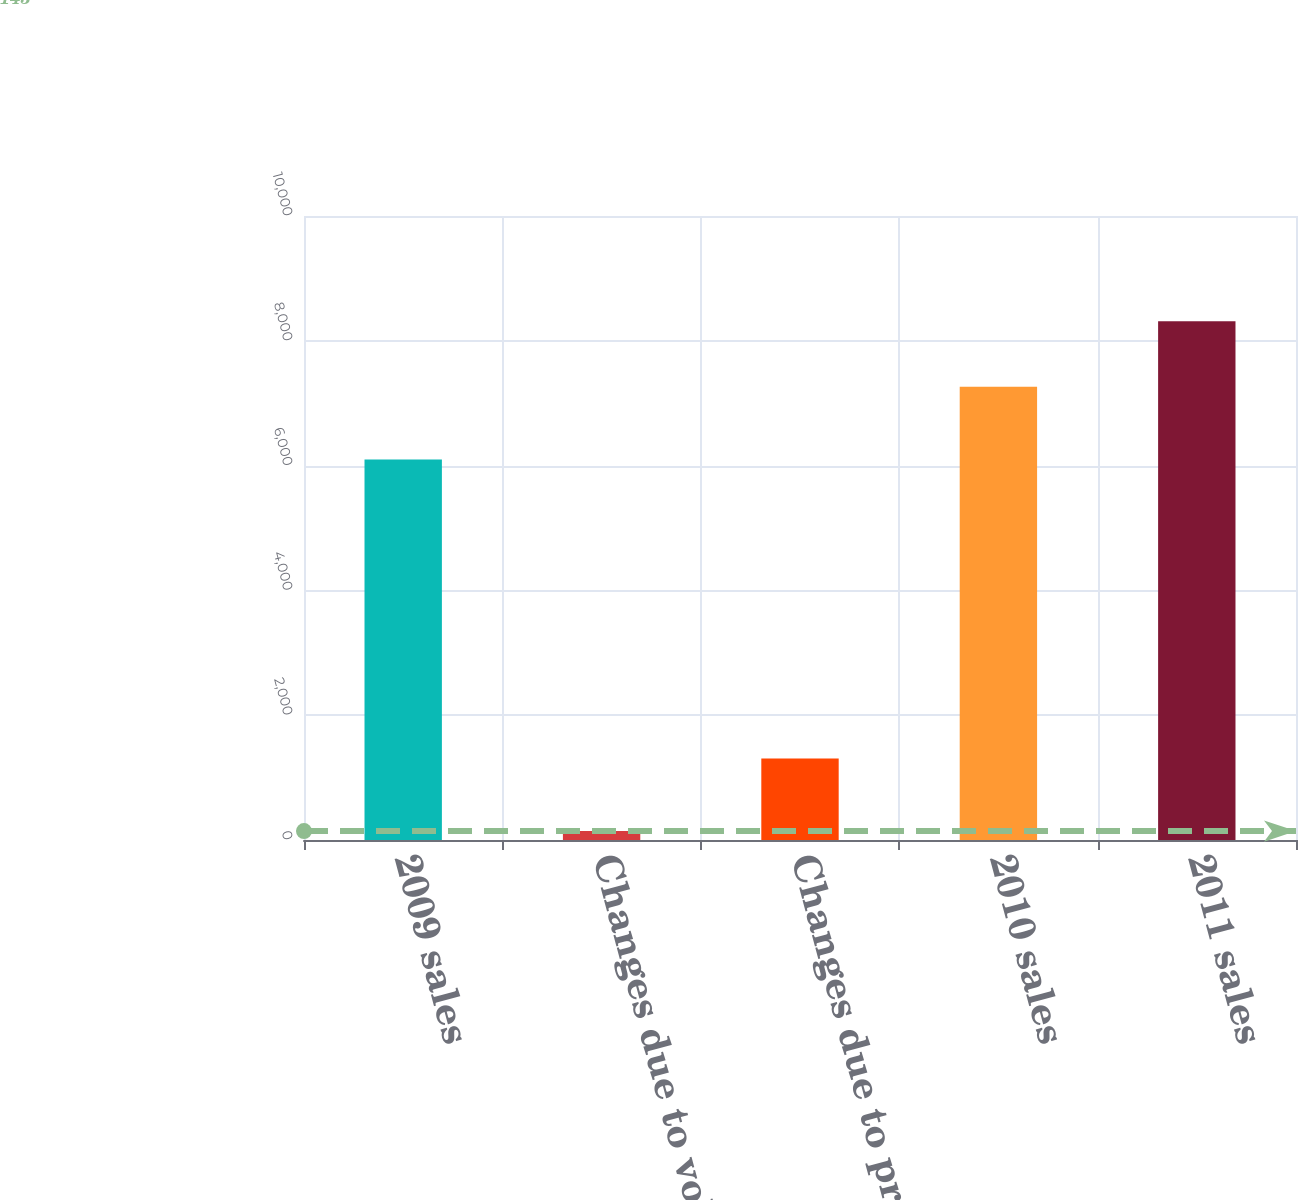<chart> <loc_0><loc_0><loc_500><loc_500><bar_chart><fcel>2009 sales<fcel>Changes due to volumes<fcel>Changes due to prices<fcel>2010 sales<fcel>2011 sales<nl><fcel>6097<fcel>143<fcel>1308<fcel>7262<fcel>8315<nl></chart> 